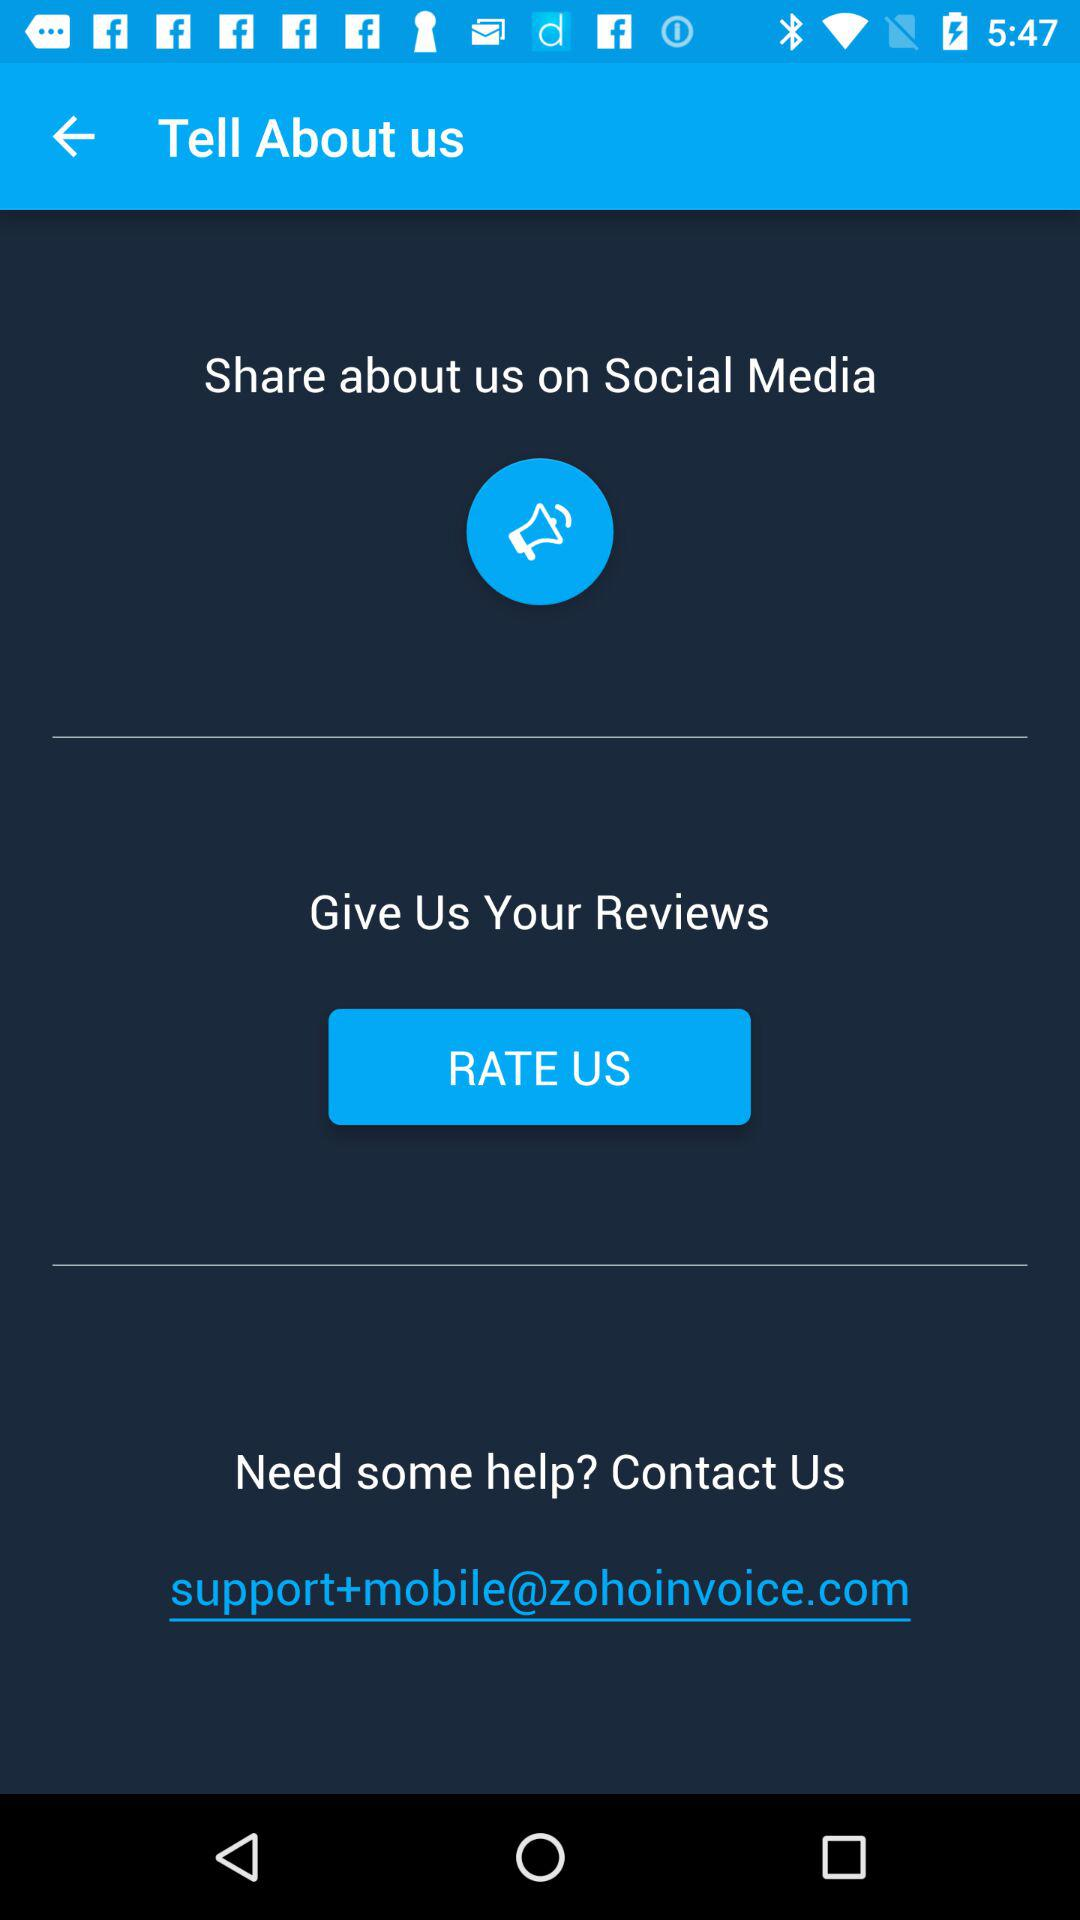What is the email address given to contact for help?
Answer the question using a single word or phrase. The email address is support+mobile@zohoinvoice.com 